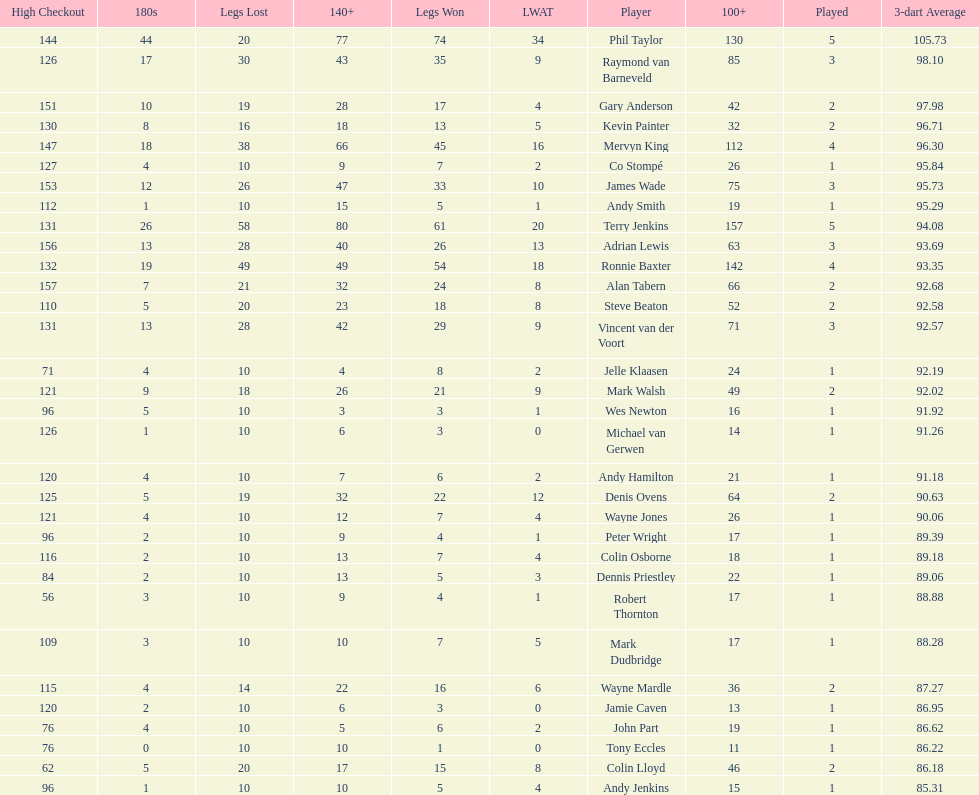Which player has his high checkout as 116? Colin Osborne. 